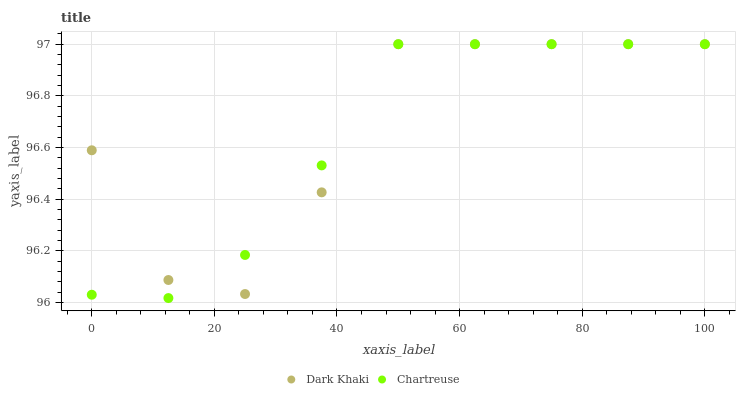Does Chartreuse have the minimum area under the curve?
Answer yes or no. Yes. Does Dark Khaki have the maximum area under the curve?
Answer yes or no. Yes. Does Chartreuse have the maximum area under the curve?
Answer yes or no. No. Is Chartreuse the smoothest?
Answer yes or no. Yes. Is Dark Khaki the roughest?
Answer yes or no. Yes. Is Chartreuse the roughest?
Answer yes or no. No. Does Chartreuse have the lowest value?
Answer yes or no. Yes. Does Chartreuse have the highest value?
Answer yes or no. Yes. Does Dark Khaki intersect Chartreuse?
Answer yes or no. Yes. Is Dark Khaki less than Chartreuse?
Answer yes or no. No. Is Dark Khaki greater than Chartreuse?
Answer yes or no. No. 